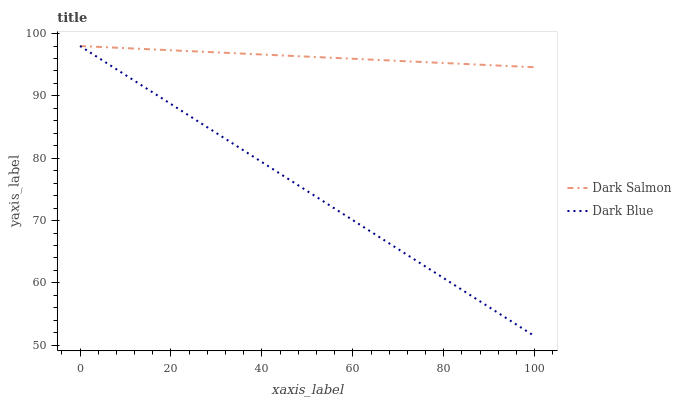Does Dark Salmon have the minimum area under the curve?
Answer yes or no. No. Is Dark Salmon the roughest?
Answer yes or no. No. Does Dark Salmon have the lowest value?
Answer yes or no. No. 